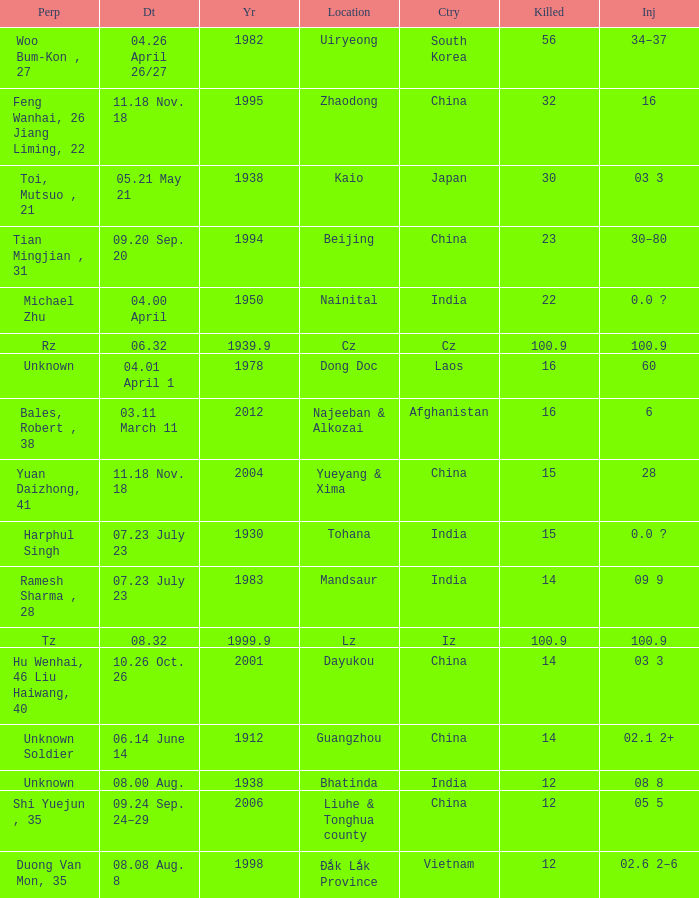What is Country, when Killed is "100.9", and when Year is greater than 1939.9? Iz. 